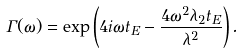Convert formula to latex. <formula><loc_0><loc_0><loc_500><loc_500>\Gamma ( \omega ) = \exp \left ( 4 i \omega t _ { E } - \frac { 4 \omega ^ { 2 } \lambda _ { 2 } t _ { E } } { \lambda ^ { 2 } } \right ) .</formula> 